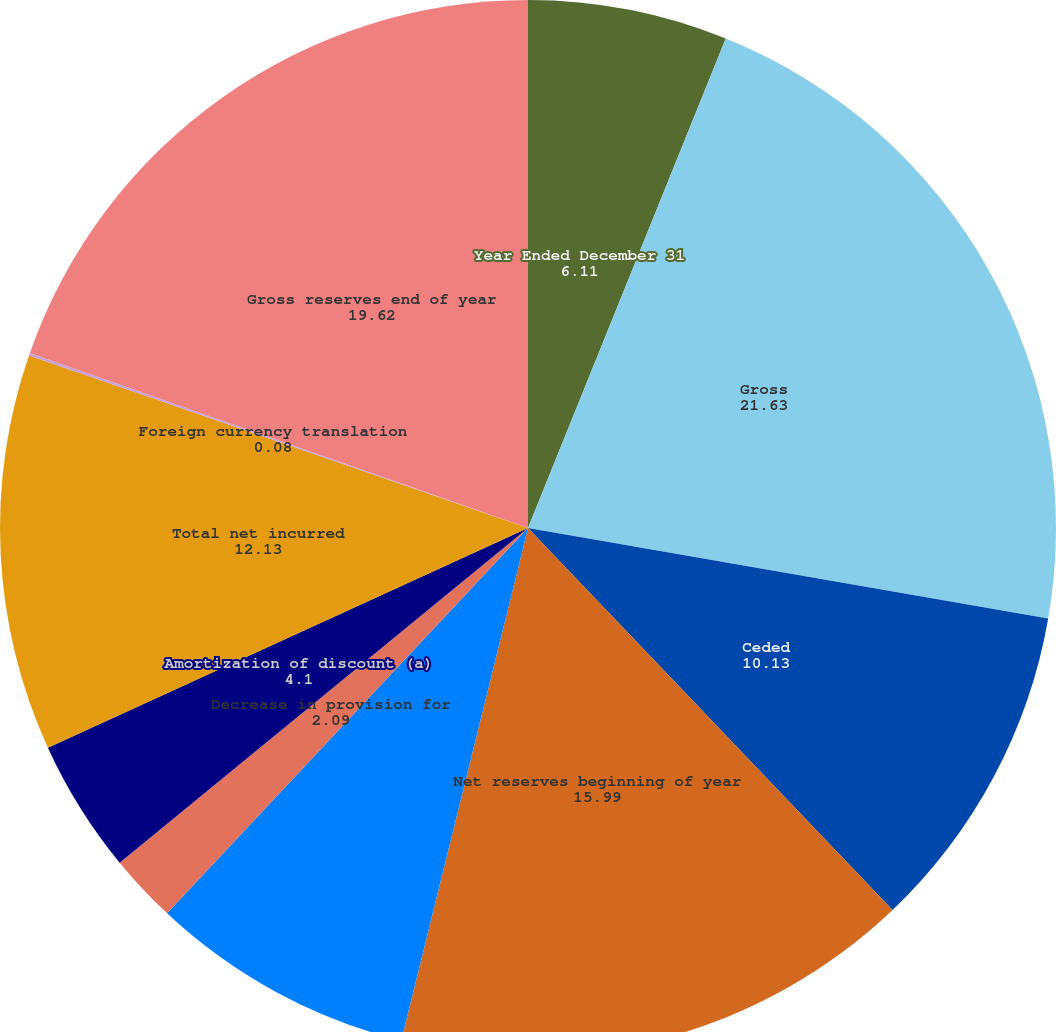<chart> <loc_0><loc_0><loc_500><loc_500><pie_chart><fcel>Year Ended December 31<fcel>Gross<fcel>Ceded<fcel>Net reserves beginning of year<fcel>Provision for insured events<fcel>Decrease in provision for<fcel>Amortization of discount (a)<fcel>Total net incurred<fcel>Foreign currency translation<fcel>Gross reserves end of year<nl><fcel>6.11%<fcel>21.63%<fcel>10.13%<fcel>15.99%<fcel>8.12%<fcel>2.09%<fcel>4.1%<fcel>12.13%<fcel>0.08%<fcel>19.62%<nl></chart> 